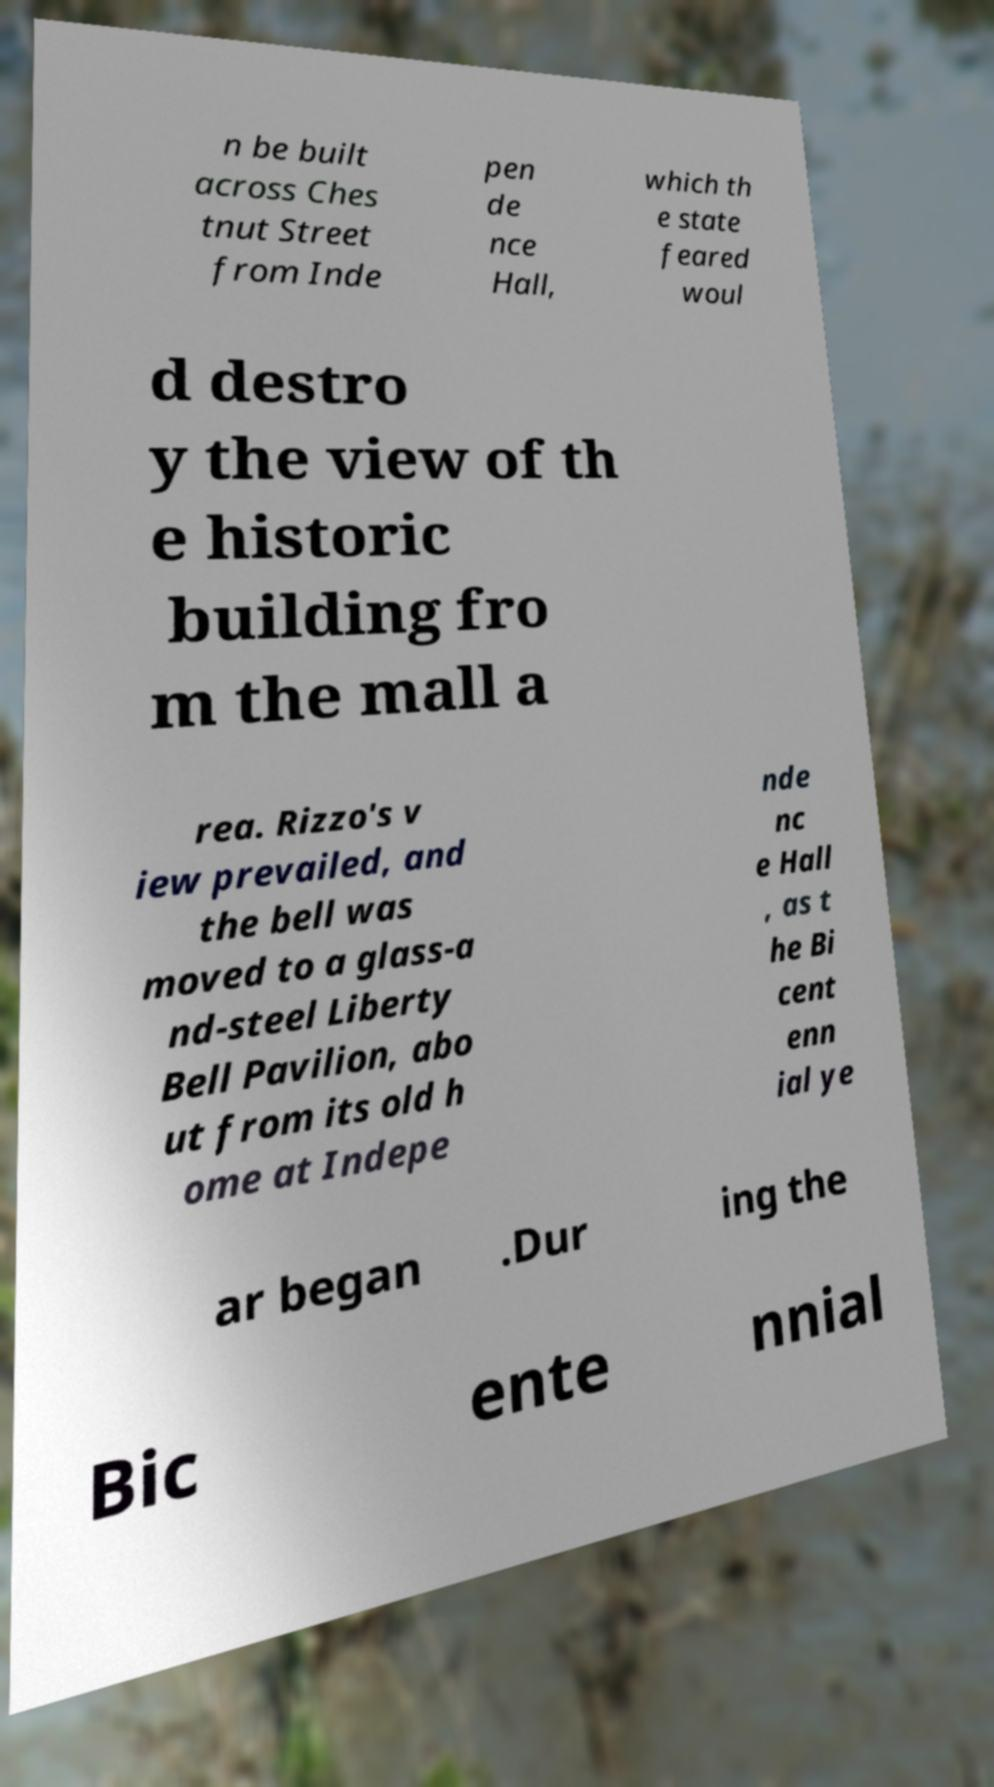Could you extract and type out the text from this image? n be built across Ches tnut Street from Inde pen de nce Hall, which th e state feared woul d destro y the view of th e historic building fro m the mall a rea. Rizzo's v iew prevailed, and the bell was moved to a glass-a nd-steel Liberty Bell Pavilion, abo ut from its old h ome at Indepe nde nc e Hall , as t he Bi cent enn ial ye ar began .Dur ing the Bic ente nnial 